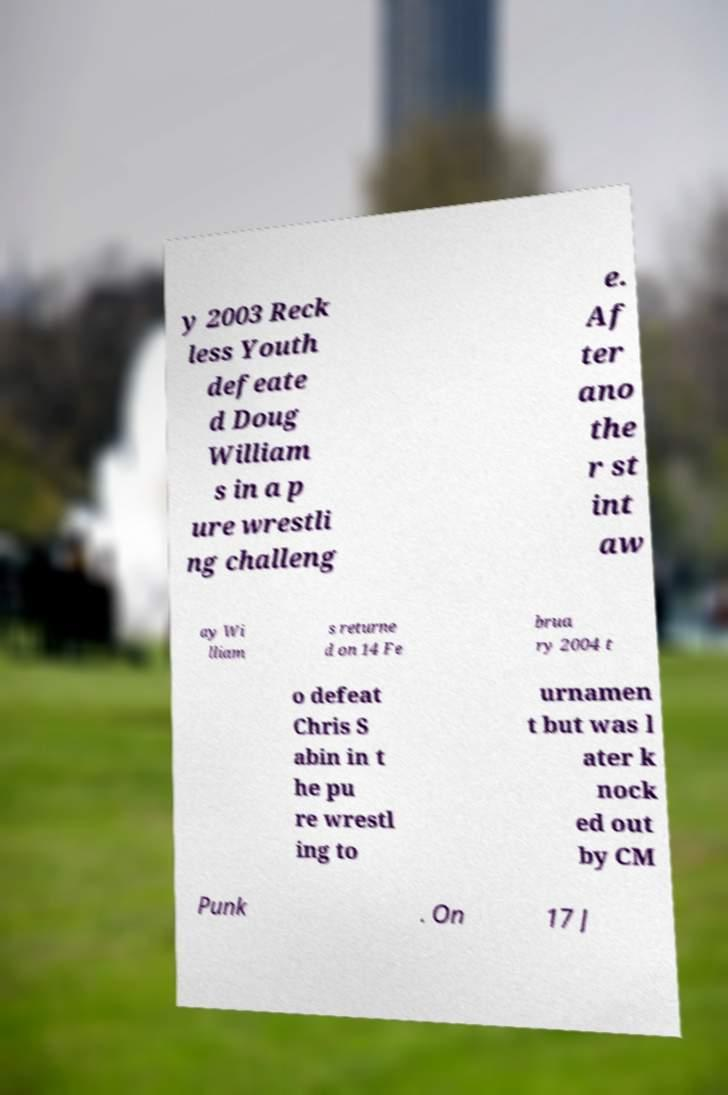Could you assist in decoding the text presented in this image and type it out clearly? y 2003 Reck less Youth defeate d Doug William s in a p ure wrestli ng challeng e. Af ter ano the r st int aw ay Wi lliam s returne d on 14 Fe brua ry 2004 t o defeat Chris S abin in t he pu re wrestl ing to urnamen t but was l ater k nock ed out by CM Punk . On 17 J 